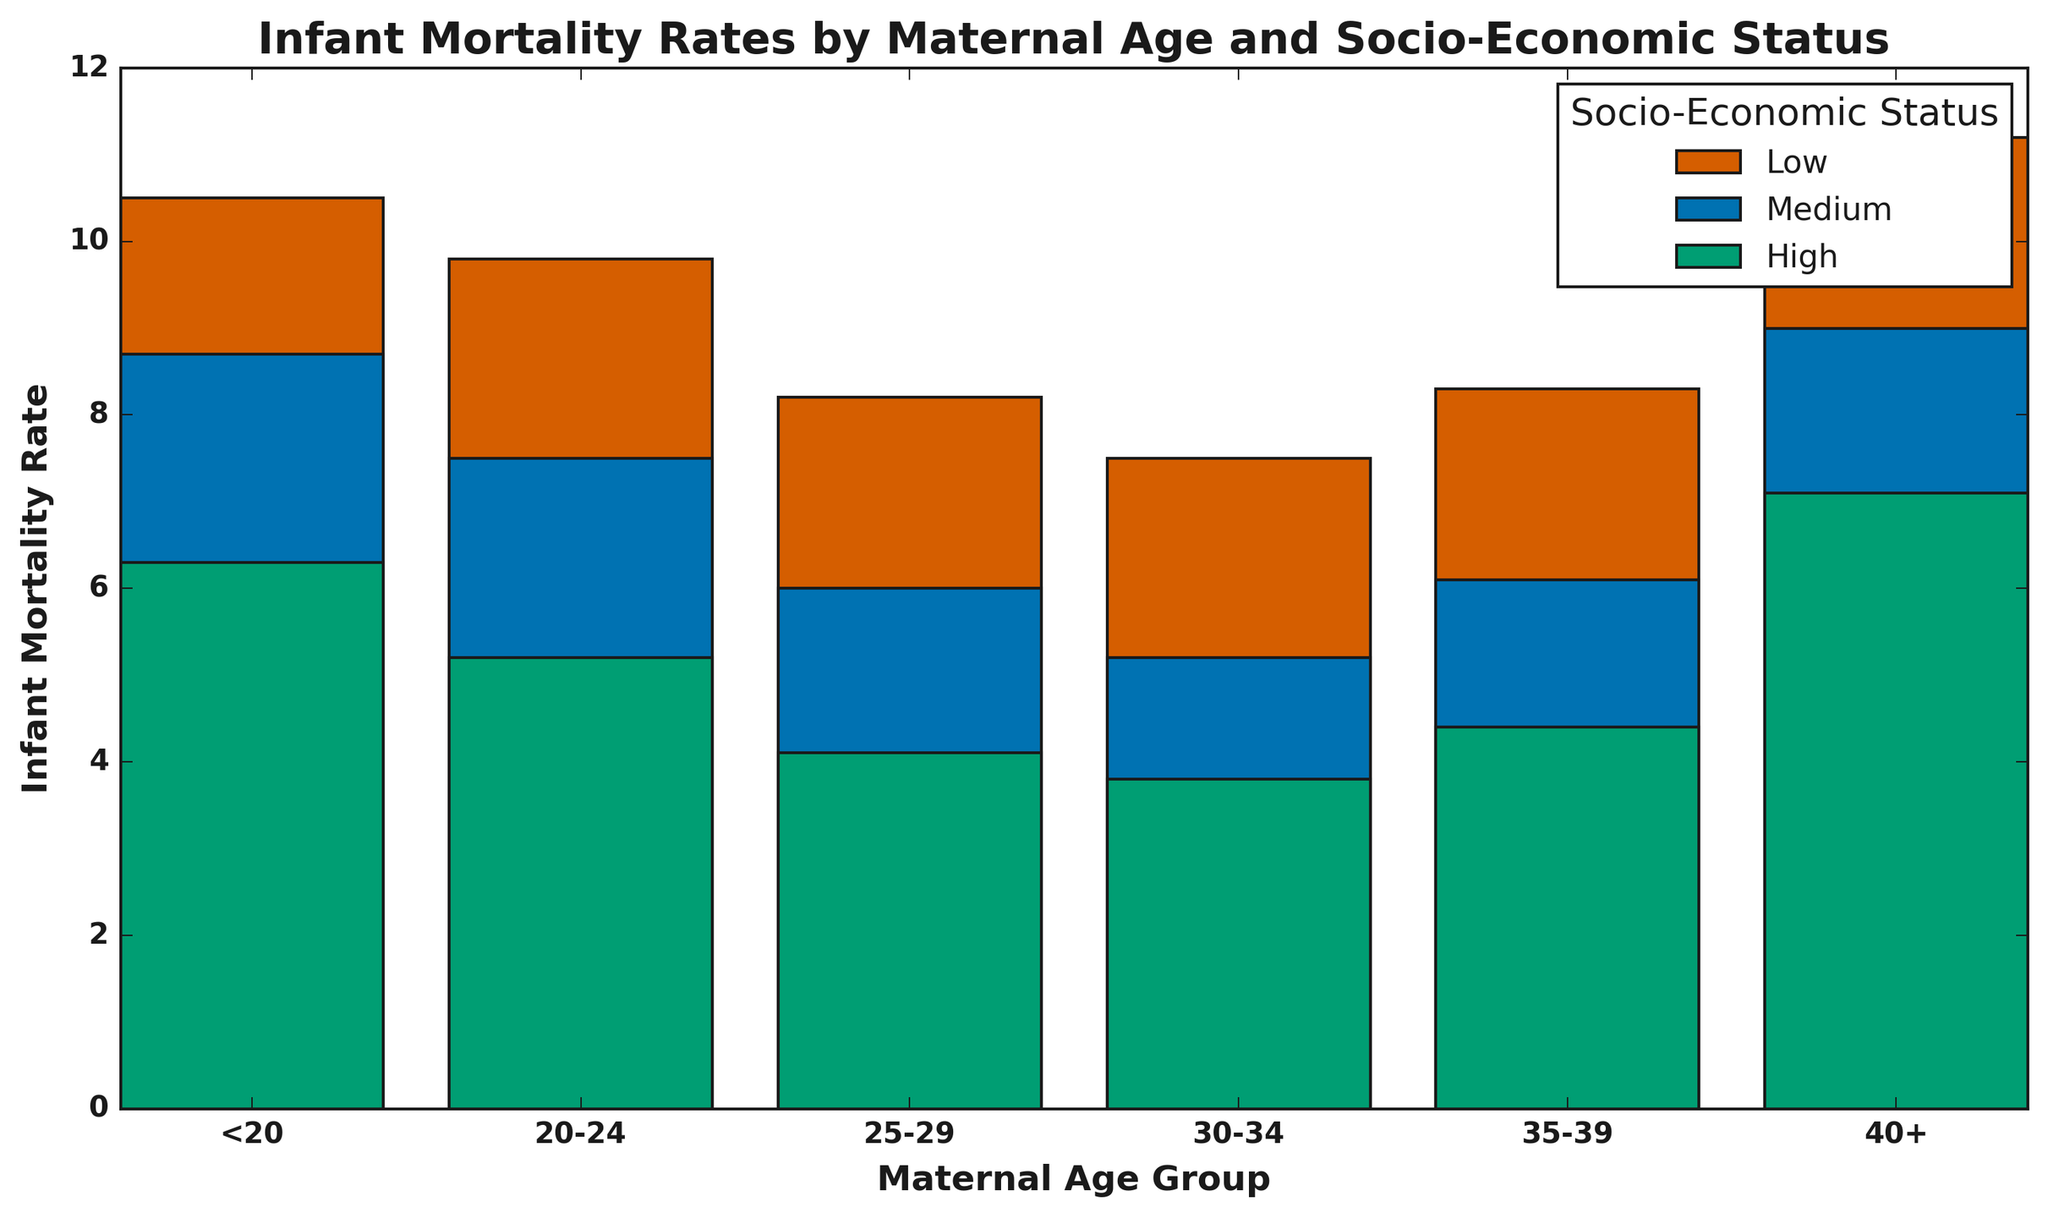What is the infant mortality rate for the lowest socio-economic status in the 25-29 age group? Locate the "Low" socio-economic status for the 25-29 age group and note the corresponding infant mortality rate.
Answer: 8.2 Which maternal age group has the highest infant mortality rate for high socio-economic status? Compare the infant mortality rates within the high socio-economic status across all maternal age groups and identify the highest value.
Answer: 40+ By how much does the infant mortality rate change when moving from low to high socio-economic status in the <20 age group? Extract the infant mortality rates for low and high socio-economic statuses in the <20 age group and calculate the difference.
Answer: 4.2 Which socio-economic status has the lowest infant mortality rate in the 30-34 age group? Examine the infant mortality rates for all socio-economic statuses within the 30-34 age group and find the lowest value.
Answer: High How does the infant mortality rate for the 20-24 age group with medium socio-economic status compare to the 35-39 age group with low socio-economic status? Compare the specific values for the 20-24 age group with medium socio-economic status and the 35-39 age group with low socio-economic status.
Answer: 20-24 (medium) is lower than 35-39 (low) What is the average infant mortality rate for the medium socio-economic status across all age groups? Sum the infant mortality rates for medium socio-economic status across all age groups and divide by the number of age groups.
Answer: 7.1 Does the infant mortality rate generally increase or decrease with higher socio-economic status within each maternal age group? Observe the trend in infant mortality rates across low, medium, and high socio-economic statuses within each maternal age group.
Answer: Decrease Which maternal age group with low socio-economic status has the second lowest infant mortality rate? Locate and compare the infant mortality rates for low socio-economic status across all maternal age groups and identify the second lowest value.
Answer: 30-34 By what factor does the infant mortality rate in the <20 age group with low socio-economic status differ from the 30-34 age group with high socio-economic status? Divide the infant mortality rate of the <20 age group with low socio-economic status by that of the 30-34 age group with high socio-economic status.
Answer: 2.76 